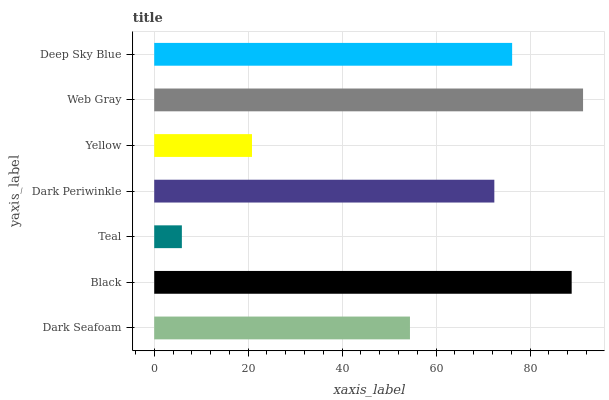Is Teal the minimum?
Answer yes or no. Yes. Is Web Gray the maximum?
Answer yes or no. Yes. Is Black the minimum?
Answer yes or no. No. Is Black the maximum?
Answer yes or no. No. Is Black greater than Dark Seafoam?
Answer yes or no. Yes. Is Dark Seafoam less than Black?
Answer yes or no. Yes. Is Dark Seafoam greater than Black?
Answer yes or no. No. Is Black less than Dark Seafoam?
Answer yes or no. No. Is Dark Periwinkle the high median?
Answer yes or no. Yes. Is Dark Periwinkle the low median?
Answer yes or no. Yes. Is Web Gray the high median?
Answer yes or no. No. Is Black the low median?
Answer yes or no. No. 